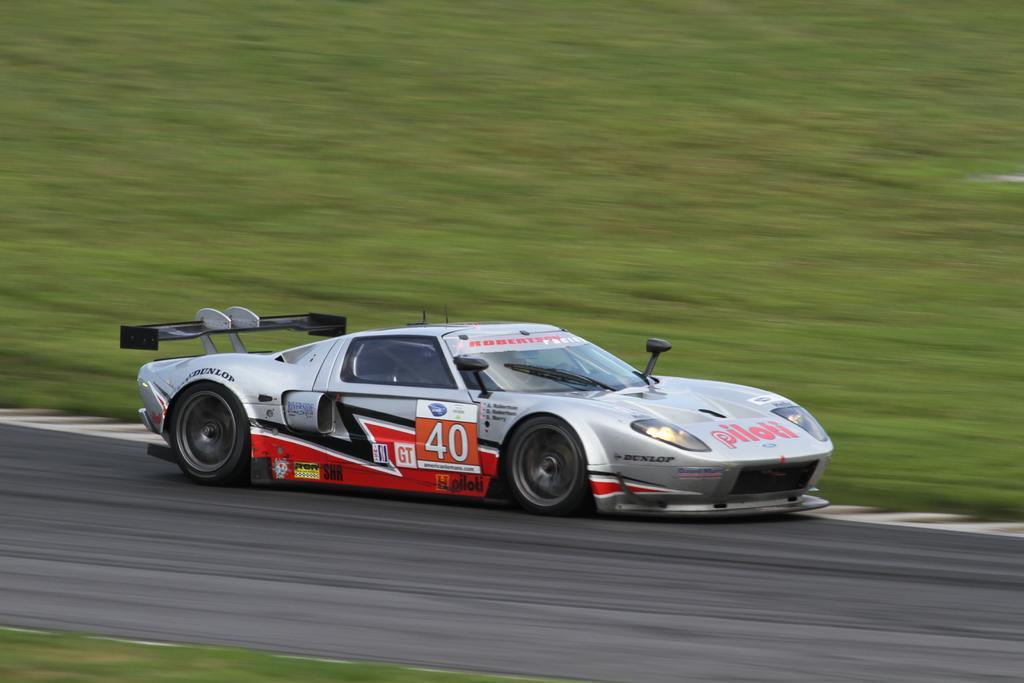Can you describe this image briefly? A sports car is moving on the road, it is in silver color. This is the grass in this image. 